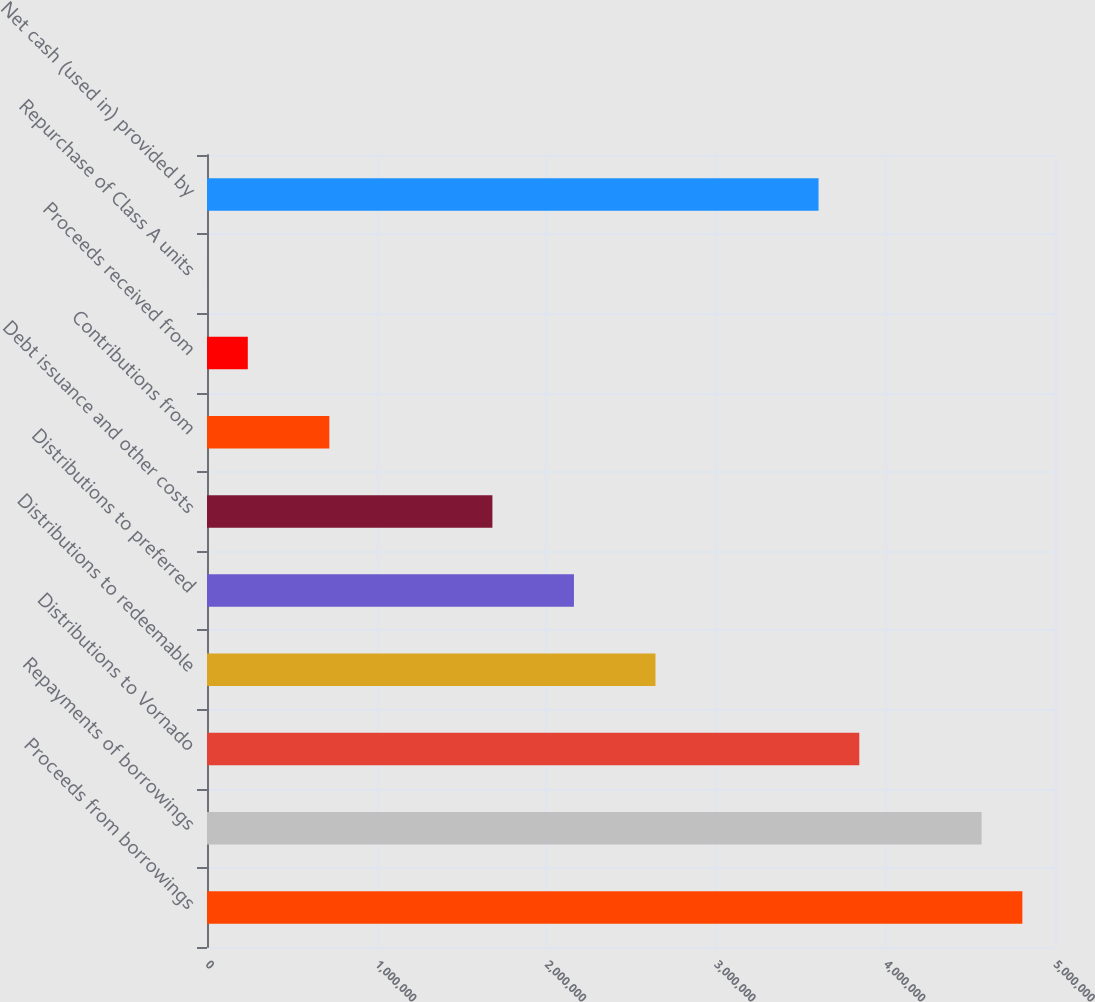Convert chart to OTSL. <chart><loc_0><loc_0><loc_500><loc_500><bar_chart><fcel>Proceeds from borrowings<fcel>Repayments of borrowings<fcel>Distributions to Vornado<fcel>Distributions to redeemable<fcel>Distributions to preferred<fcel>Debt issuance and other costs<fcel>Contributions from<fcel>Proceeds received from<fcel>Repurchase of Class A units<fcel>Net cash (used in) provided by<nl><fcel>4.80761e+06<fcel>4.56724e+06<fcel>3.84613e+06<fcel>2.64427e+06<fcel>2.16353e+06<fcel>1.68278e+06<fcel>721300<fcel>240557<fcel>186<fcel>3.60575e+06<nl></chart> 